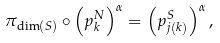Convert formula to latex. <formula><loc_0><loc_0><loc_500><loc_500>\pi _ { \dim \left ( S \right ) } \circ \left ( p _ { k } ^ { N } \right ) ^ { \alpha } = \left ( p _ { j \left ( k \right ) } ^ { S } \right ) ^ { \alpha } ,</formula> 